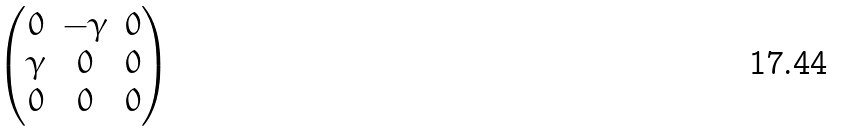<formula> <loc_0><loc_0><loc_500><loc_500>\begin{pmatrix} 0 & - \gamma & 0 \\ \gamma & 0 & 0 \\ 0 & 0 & 0 \\ \end{pmatrix}</formula> 